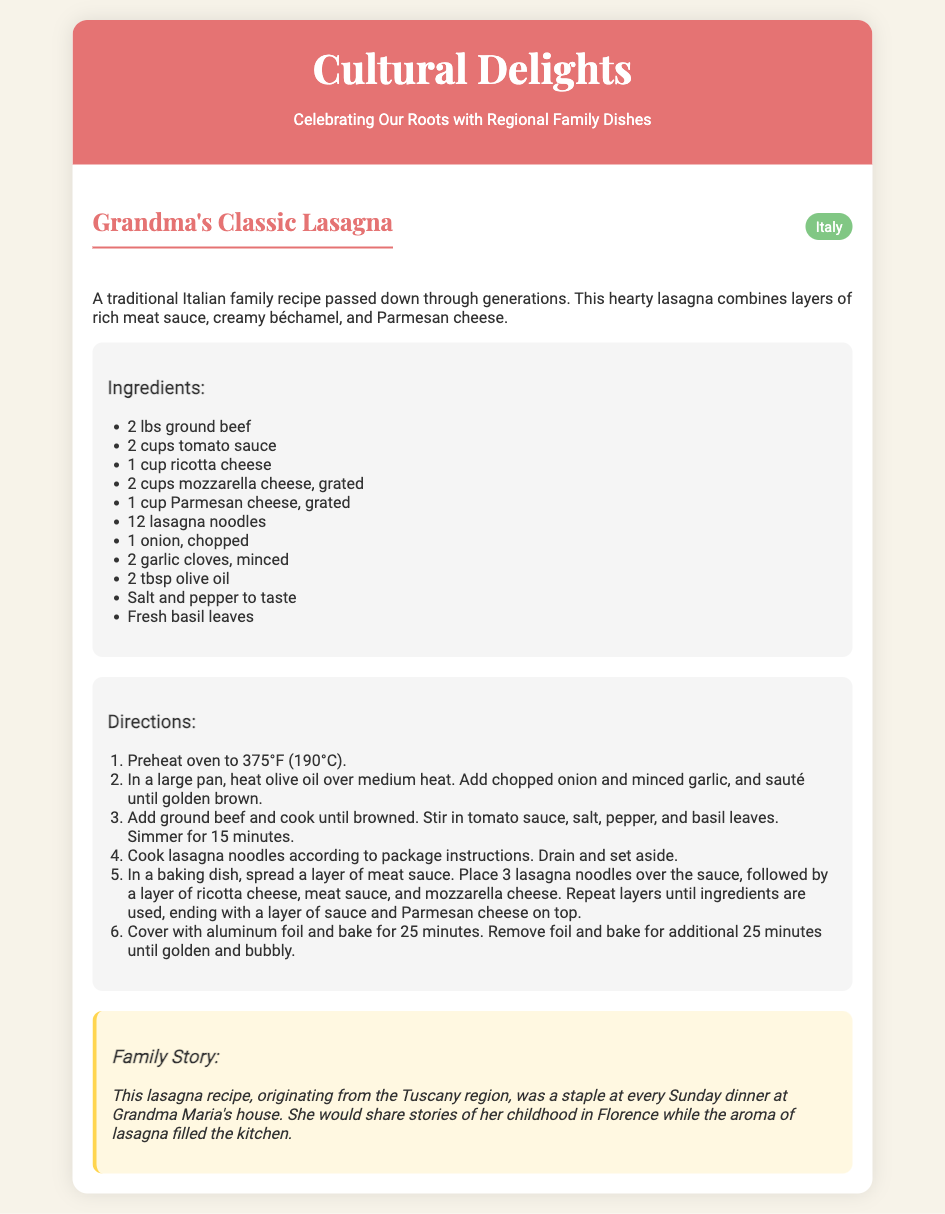What is the name of the dish? The name of the dish is mentioned prominently in the header of the recipe section.
Answer: Grandma's Classic Lasagna What region does this recipe originate from? The region is indicated next to the dish name in the recipe header.
Answer: Italy How many pounds of ground beef are needed? The quantity is specified in the ingredients section of the recipe.
Answer: 2 lbs What is the cooking temperature for the oven? The cooking temperature is provided as part of the directions.
Answer: 375°F How many layers should be constructed in the lasagna? The method to assemble the lasagna involves repeated layers until the ingredients are used, indicating this detail in the directions.
Answer: Multiple layers What is Grandma Maria's hometown? The family story mentions her childhood location, providing insight into her background.
Answer: Florence What cooking method is required for the lasagna noodles? The method for preparing the noodles is included in the cooking instructions.
Answer: Cook according to package instructions How long should the lasagna bake covered with aluminum foil? The duration of baking covered is outlined in the directions.
Answer: 25 minutes 